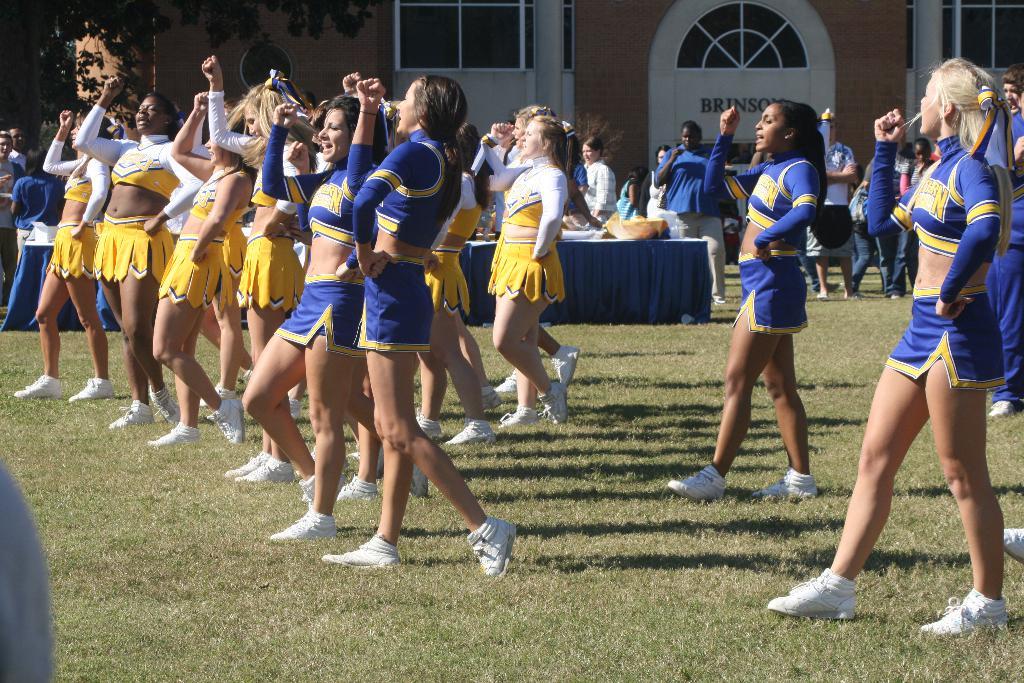What name is on the building in the back?
Keep it short and to the point. Brinson. 